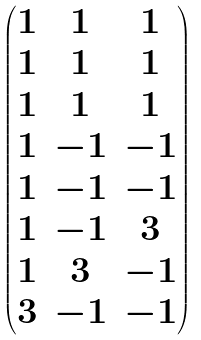Convert formula to latex. <formula><loc_0><loc_0><loc_500><loc_500>\begin{pmatrix} 1 & 1 & 1 \\ 1 & 1 & 1 \\ 1 & 1 & 1 \\ 1 & - 1 & - 1 \\ 1 & - 1 & - 1 \\ 1 & - 1 & 3 \\ 1 & 3 & - 1 \\ 3 & - 1 & - 1 \end{pmatrix}</formula> 